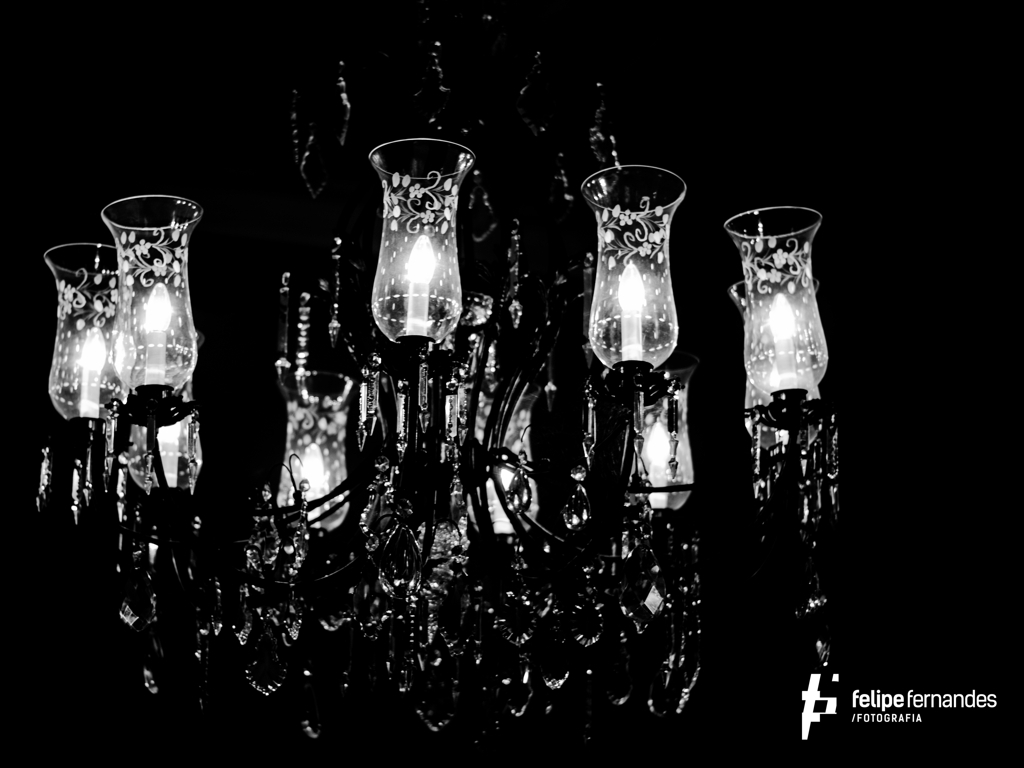What is the overall image quality? The overall image quality appears quite high. It features a strong contrast between light and dark, sharp focus on the ornate glass elements and crisp details that convey a sense of elegance. The monochromatic color scheme accentuates the lighting and the intricate designs on the glass. 